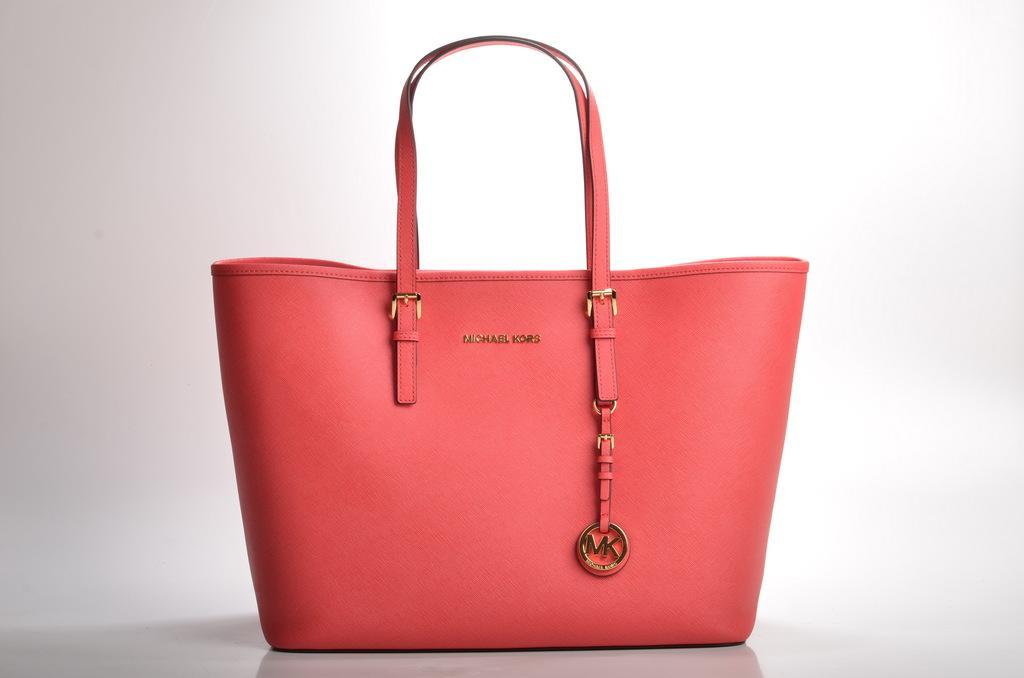Could you give a brief overview of what you see in this image? Here is a bag in red color. This back has hangings to it and on the top of the bag, it is written as Michael Kurd and on the bottom of the bag it is written as MK. This bag is placed on a table and on background it is white in color. 